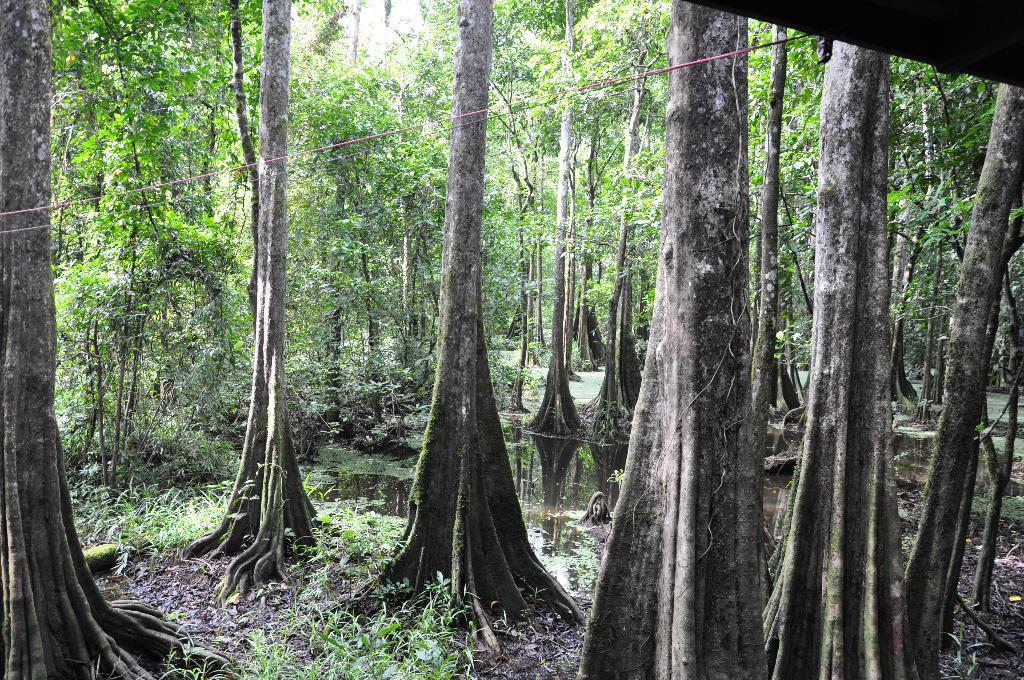What type of vegetation is present on the ground in the image? There are trees and plants on the ground in the image. What natural element can be seen in the image? There is water visible in the image. What color is the wire that is visible in the image? There is a red color wire in the image. What type of army is depicted in the image? There is no army present in the image; it features trees, plants, water, and a red wire. What is the end result of the flesh in the image? There is no flesh present in the image, so it is not possible to determine an end result. 